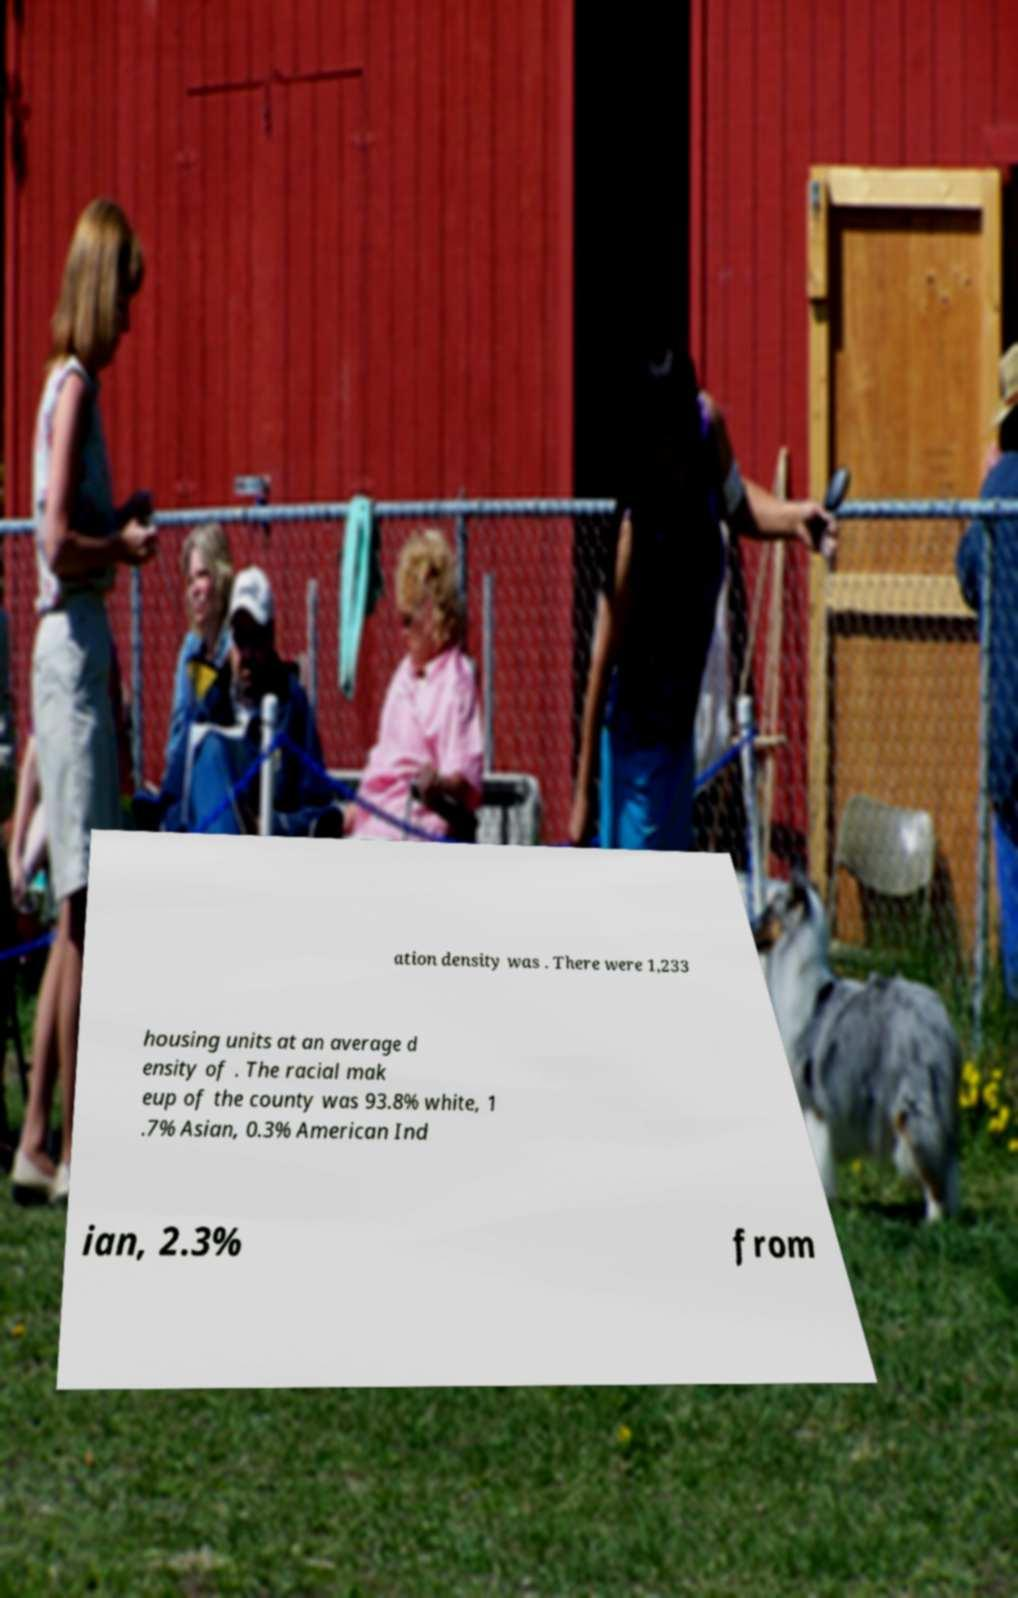Can you read and provide the text displayed in the image?This photo seems to have some interesting text. Can you extract and type it out for me? ation density was . There were 1,233 housing units at an average d ensity of . The racial mak eup of the county was 93.8% white, 1 .7% Asian, 0.3% American Ind ian, 2.3% from 